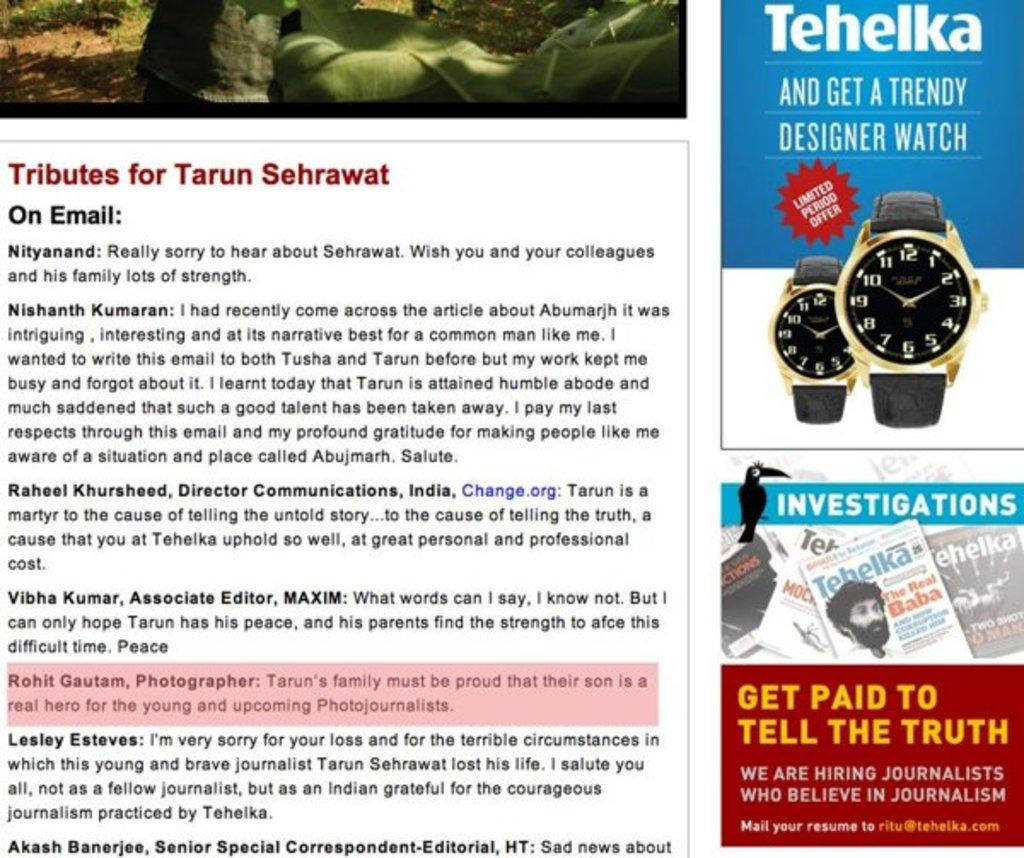<image>
Offer a succinct explanation of the picture presented. An advertisement with Tributes for Tarun Sehrawat and a watch ad for Tehelka 